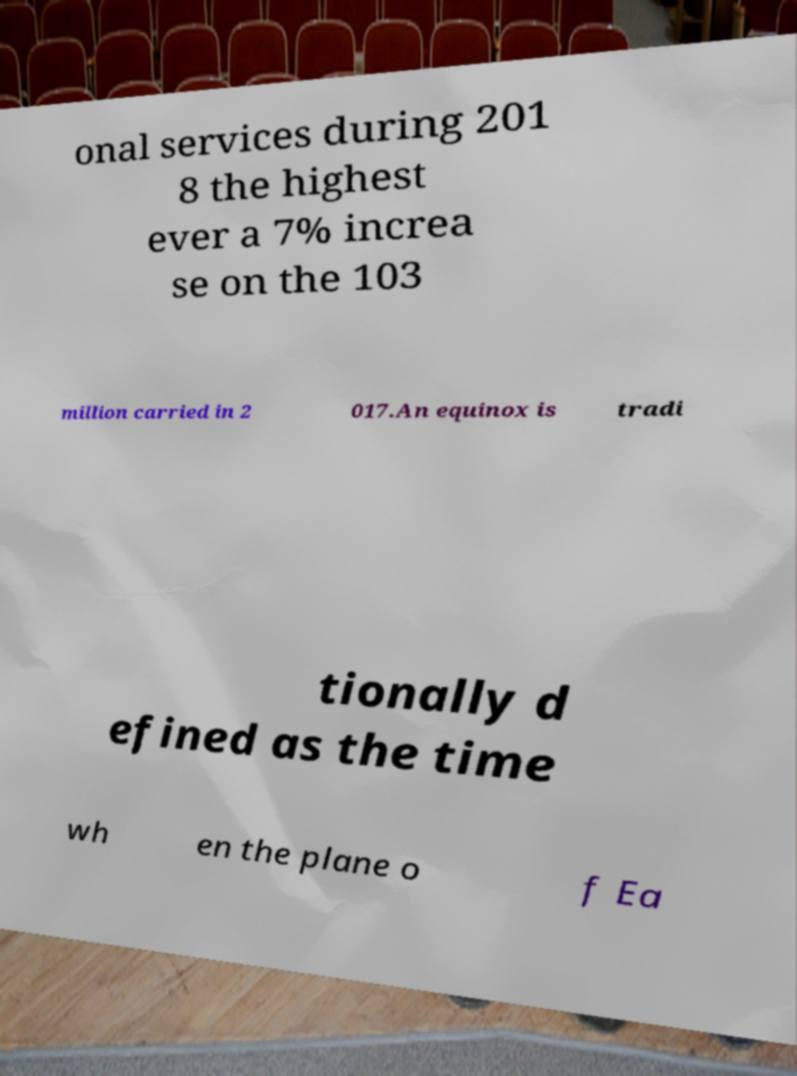I need the written content from this picture converted into text. Can you do that? onal services during 201 8 the highest ever a 7% increa se on the 103 million carried in 2 017.An equinox is tradi tionally d efined as the time wh en the plane o f Ea 